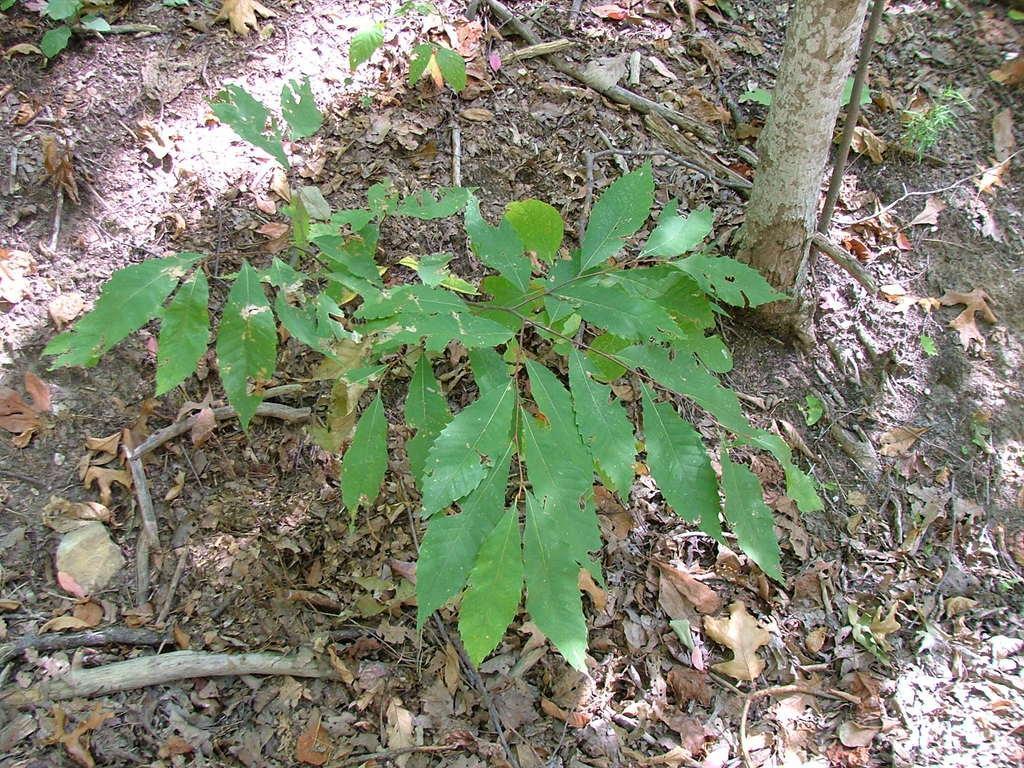Can you describe this image briefly? In this image I can see plants in green color and I can also see few dried leaves and they are in brown color. 